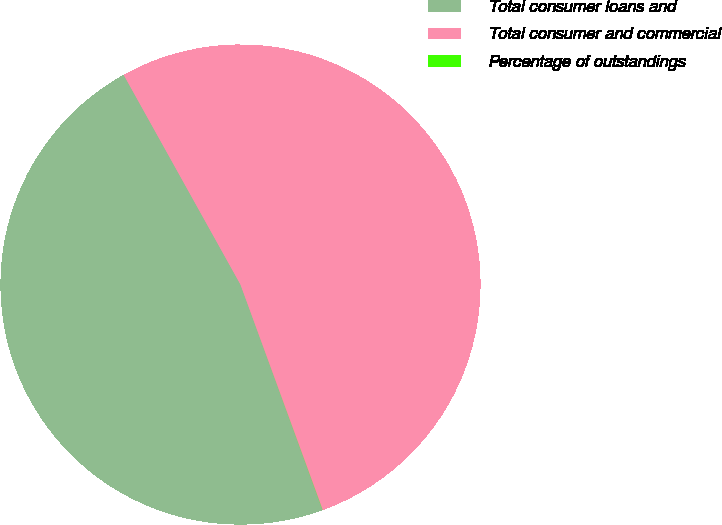Convert chart. <chart><loc_0><loc_0><loc_500><loc_500><pie_chart><fcel>Total consumer loans and<fcel>Total consumer and commercial<fcel>Percentage of outstandings<nl><fcel>47.47%<fcel>52.53%<fcel>0.01%<nl></chart> 